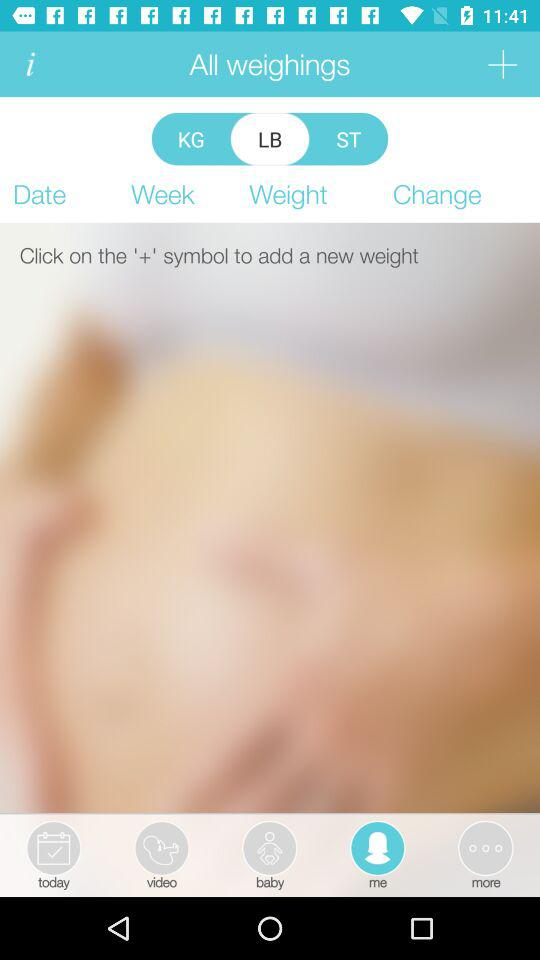Which option is selected? The selected options are "me" and "LB". 